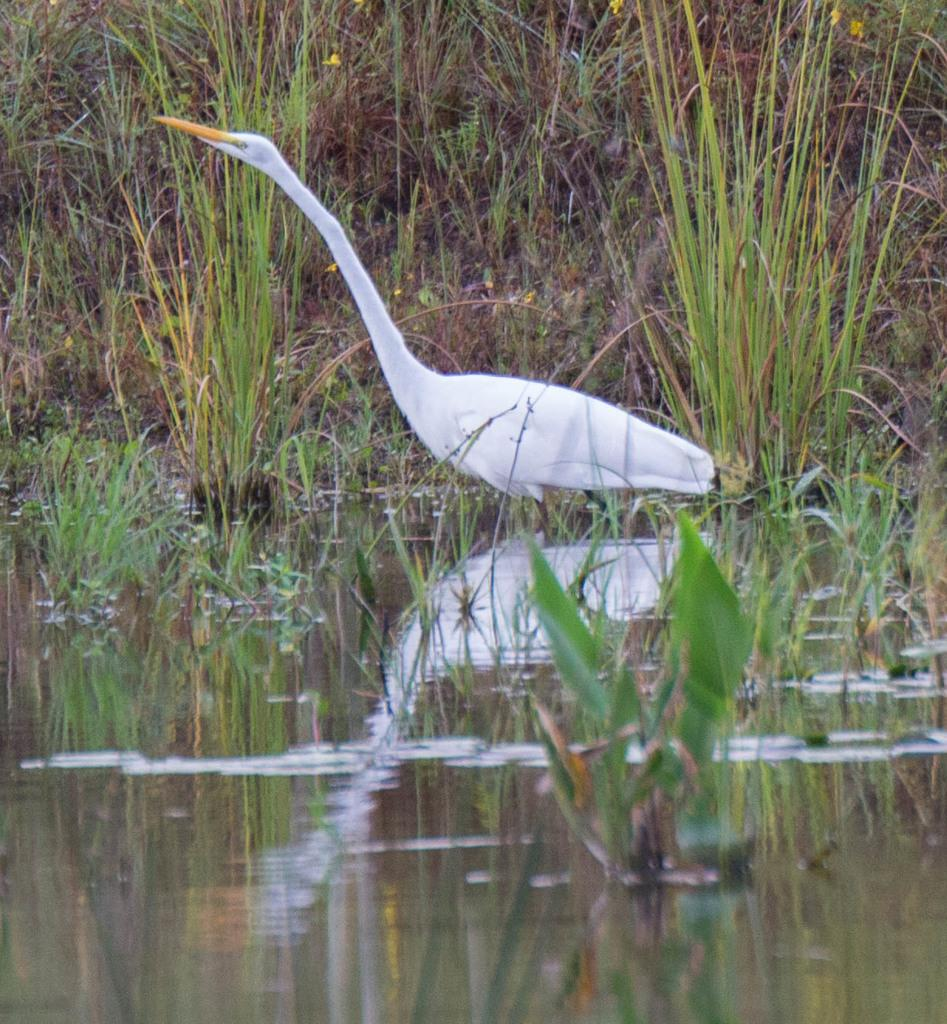What type of bird is in the image? There is a white crane in the image. Where is the crane located? The crane is in the water. What else can be seen in the image besides the crane? There are plants in the image. How much money is the crane holding in its beak in the image? The crane is not holding any money in its beak in the image. What type of conversation is the crane having with the plants in the image? The crane is not having a conversation with the plants in the image, as birds do not communicate through human language. 